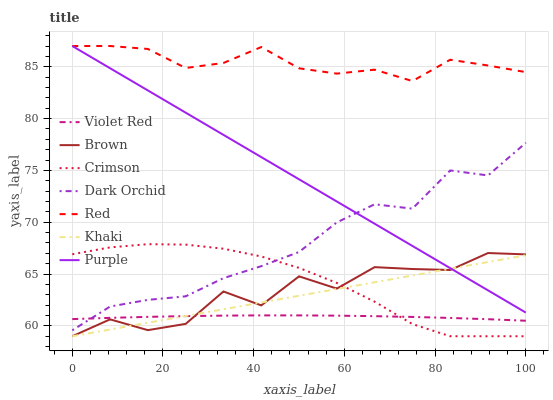Does Khaki have the minimum area under the curve?
Answer yes or no. No. Does Khaki have the maximum area under the curve?
Answer yes or no. No. Is Violet Red the smoothest?
Answer yes or no. No. Is Violet Red the roughest?
Answer yes or no. No. Does Violet Red have the lowest value?
Answer yes or no. No. Does Khaki have the highest value?
Answer yes or no. No. Is Dark Orchid less than Red?
Answer yes or no. Yes. Is Red greater than Dark Orchid?
Answer yes or no. Yes. Does Dark Orchid intersect Red?
Answer yes or no. No. 